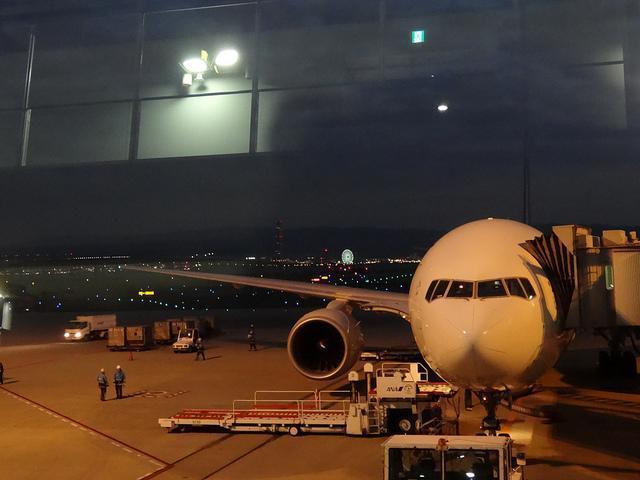How many people can be seen?
Give a very brief answer. 4. 